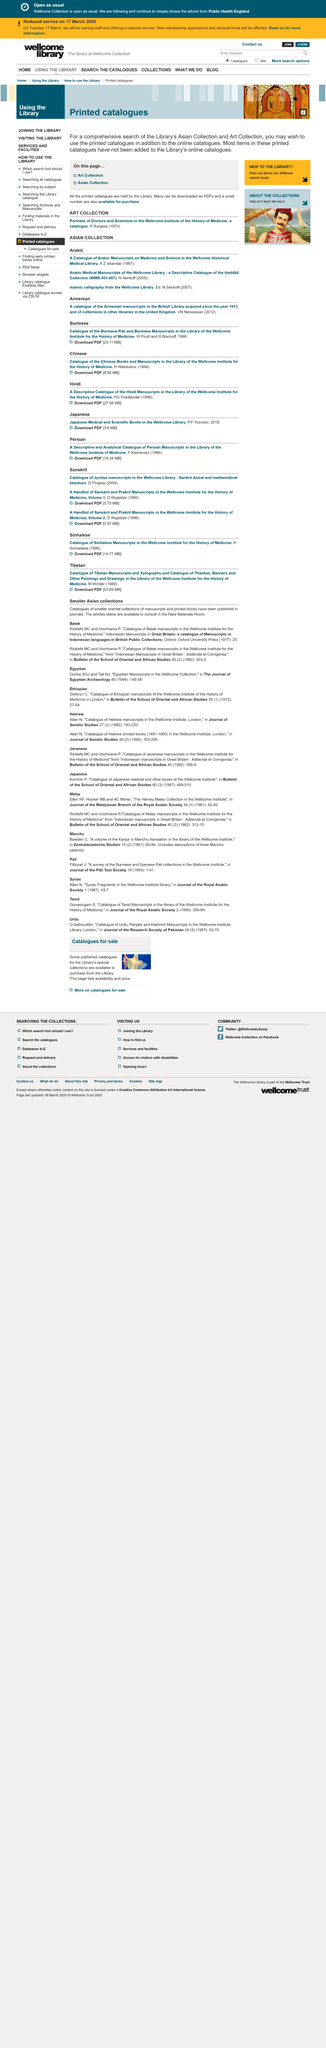Give some essential details in this illustration. The article "Catalogue of Batak manuscripts in the Wellcome Institute for the History of Medicine" was written by Ricklefs MC and Voorhoeve P. The "Catalogue of Batak manuscripts in the Wellcome Institute for the History of Medicine" can be located in the rare materials room. Catalogues of smaller collections of manuscripts have been published in journals. 